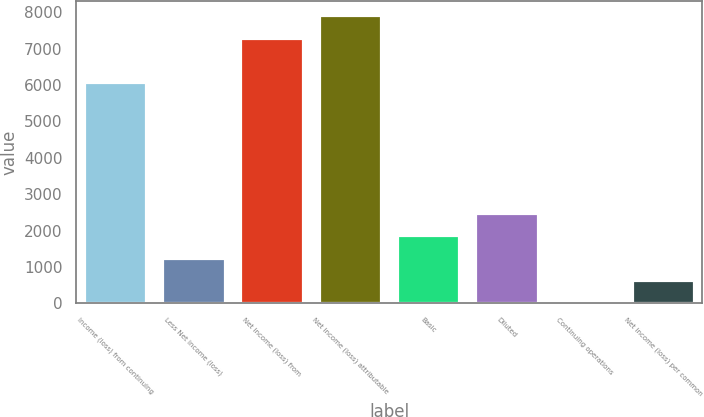Convert chart to OTSL. <chart><loc_0><loc_0><loc_500><loc_500><bar_chart><fcel>Income (loss) from continuing<fcel>Less Net income (loss)<fcel>Net income (loss) from<fcel>Net income (loss) attributable<fcel>Basic<fcel>Diluted<fcel>Continuing operations<fcel>Net income (loss) per common<nl><fcel>6076<fcel>1250.54<fcel>7306.62<fcel>7921.93<fcel>1865.85<fcel>2481.16<fcel>19.92<fcel>635.23<nl></chart> 